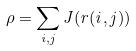<formula> <loc_0><loc_0><loc_500><loc_500>\rho = \sum _ { i , j } J ( r ( i , j ) )</formula> 